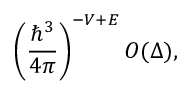Convert formula to latex. <formula><loc_0><loc_0><loc_500><loc_500>\left ( { \frac { \hbar { ^ } { 3 } } { 4 \pi } } \right ) ^ { - V + E } O ( \Delta ) ,</formula> 